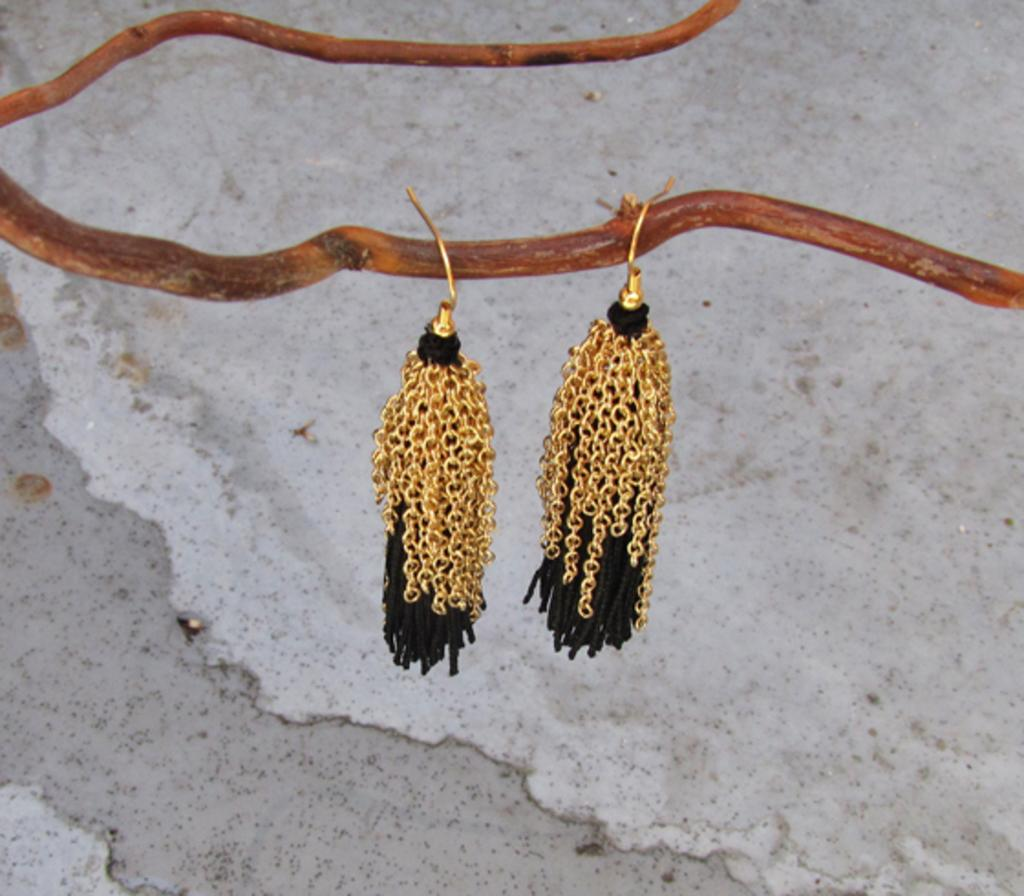What type of jewelry is present in the image? There are earrings in the image. How are the earrings positioned? The earrings are hanging from a stem. What can be seen in the background of the image? There is a wall in the background of the image. What type of truck is visible in the image? There is no truck present in the image; it features earrings hanging from a stem with a wall in the background. 